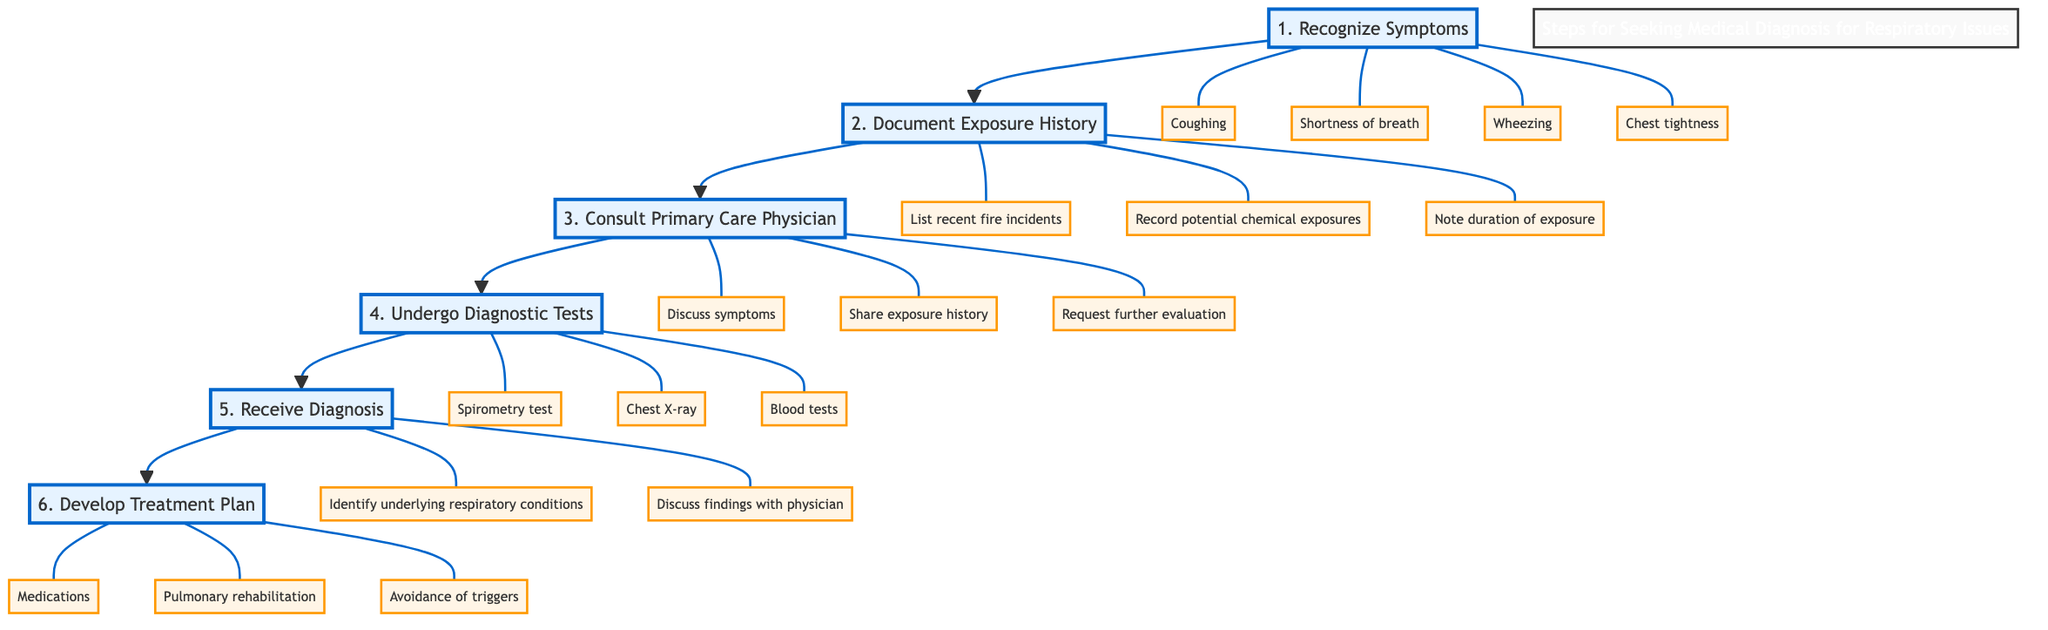What is the first step in seeking a medical diagnosis for respiratory issues? The first step is "Recognize Symptoms," which suggests starting by identifying the symptoms experienced.
Answer: Recognize Symptoms How many steps are there in the flow chart? The flow chart consists of six steps, listed sequentially from recognizing symptoms to developing a treatment plan.
Answer: 6 What symptom is NOT listed in the "Recognize Symptoms" step? The listed symptoms include coughing, shortness of breath, wheezing, and chest tightness. The absence of "sore throat" indicates it is not part of the recognized symptoms.
Answer: Sore throat What should be documented in the "Document Exposure History" step? Important aspects to document include a list of recent fire incidents, potential chemical exposures, and duration of exposure. These details capture the necessary history for the physician.
Answer: List recent fire incidents, Record potential chemical exposures, Note duration of exposure What is the last action taken in the flow chart? The last action specified in the flow chart is to "Develop Treatment Plan," indicating the final step after receiving a diagnosis.
Answer: Develop Treatment Plan Which diagnostic test is mentioned in the "Undergo Diagnostic Tests" step? Among the tests mentioned, "Spirometry test" is one of the diagnostic evaluations to assess respiratory function.
Answer: Spirometry test After consulting the primary care physician, what is expected next? After the consultation, the expected next step is to undergo diagnostic tests, highlighting the sequence following initial discussions with the physician.
Answer: Undergo Diagnostic Tests Which step directly follows "Receive Diagnosis"? The step that directly follows "Receive Diagnosis" is "Develop Treatment Plan," indicating the process of creating a management strategy based on the diagnosis.
Answer: Develop Treatment Plan What findings should be discussed after receiving the diagnosis? After receiving a diagnosis, findings related to the "underlying respiratory conditions" need to be discussed with the physician to understand the implications clearly.
Answer: Identify underlying respiratory conditions, Discuss findings with physician 